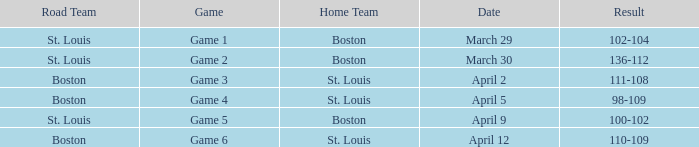What is the Game number on March 30? Game 2. 